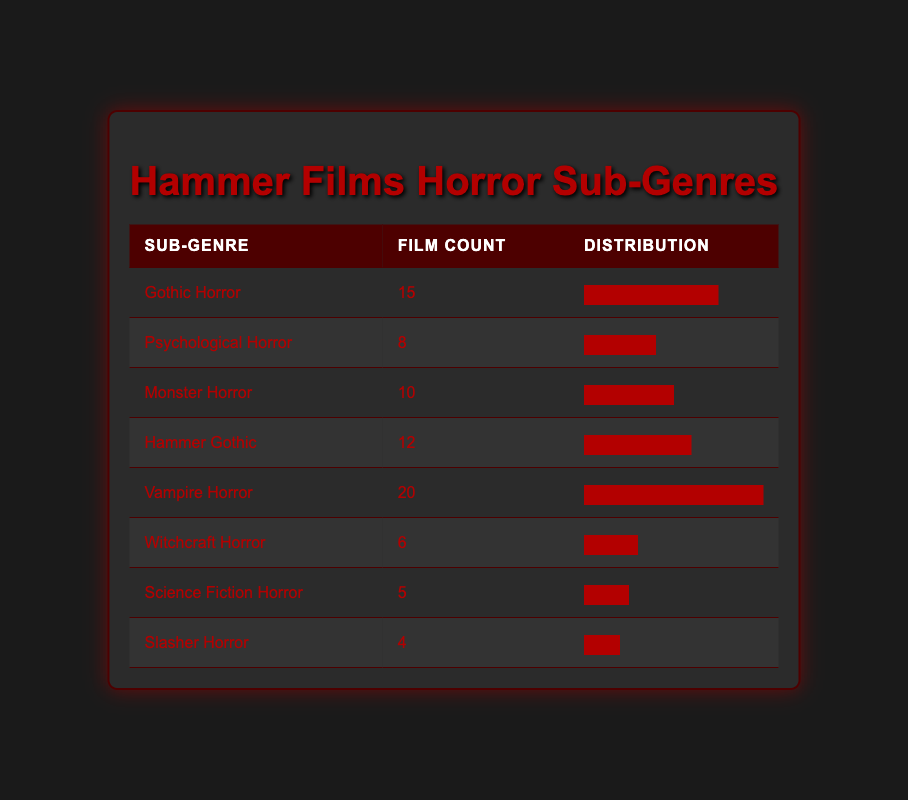What is the film count for Vampire Horror? The table shows the film count for each horror sub-genre explicitly. For Vampire Horror, the film count is listed directly next to it, which is 20.
Answer: 20 Which horror sub-genre has the least number of films? By reviewing the film counts in the table, Slasher Horror has the least number of films at 4.
Answer: Slasher Horror What is the total film count for all the listed sub-genres? To find the total film count, add up all the film counts: 15 + 8 + 10 + 12 + 20 + 6 + 5 + 4 = 80.
Answer: 80 Is there more representation in Gothic Horror than in Witchcraft Horror? Gothic Horror has a film count of 15, while Witchcraft Horror has a film count of 6. Since 15 is greater than 6, the statement is true.
Answer: Yes What percentage of Hammer films are Vampire Horror films? First, we calculate the total film count, which is 80. Vampire Horror has 20 films. To find the percentage, use the formula (20/80) * 100, which equals 25%.
Answer: 25% 